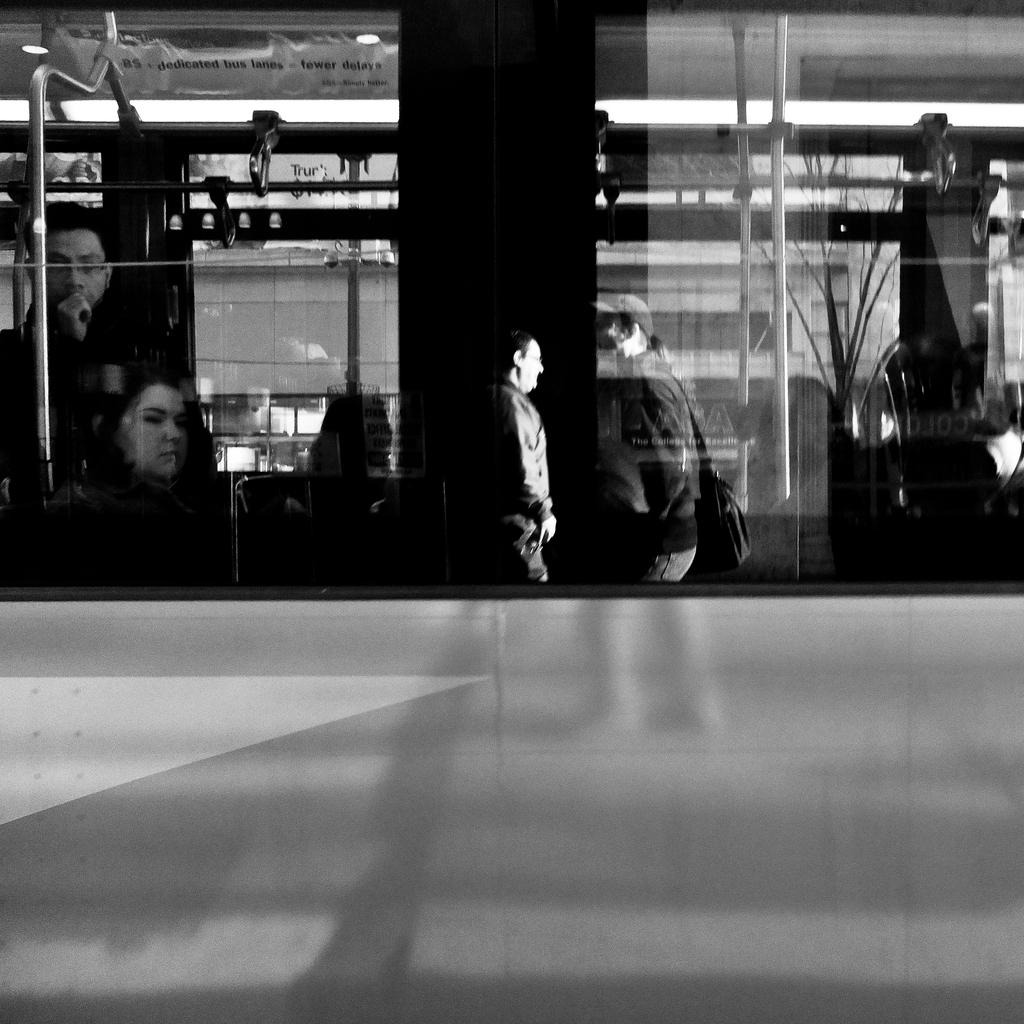What type of object is made of glass in the image? There is a glass object in the image. What can be seen through the glass object? People, rods, and other unspecified things are visible through the glass object. What year is depicted in the art piece visible through the glass object? There is no art piece or specific year mentioned in the image, so it cannot be determined. 